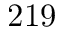<formula> <loc_0><loc_0><loc_500><loc_500>2 1 9</formula> 